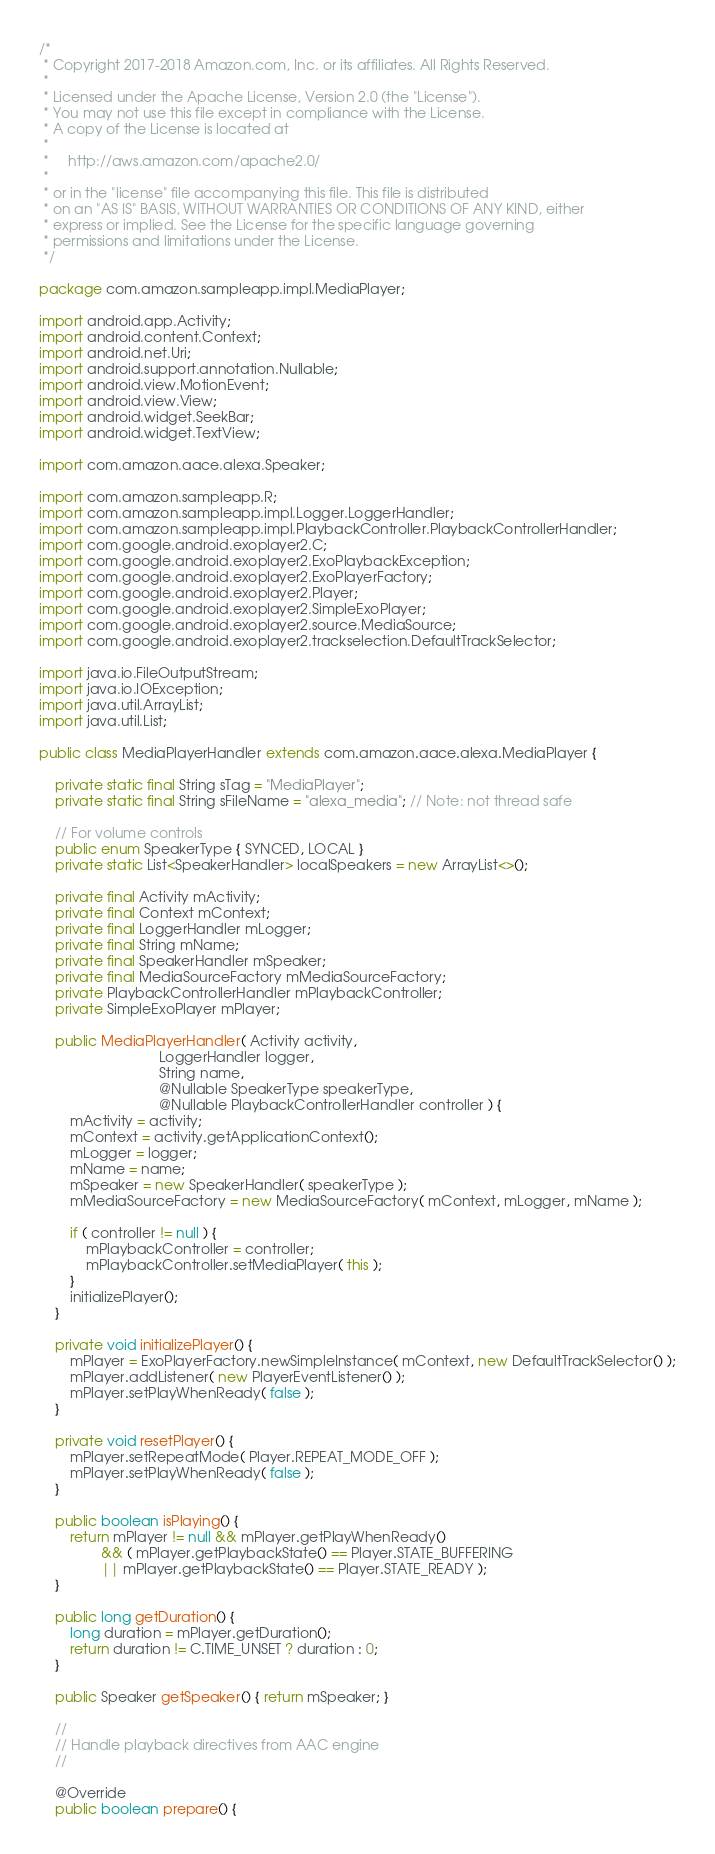<code> <loc_0><loc_0><loc_500><loc_500><_Java_>/*
 * Copyright 2017-2018 Amazon.com, Inc. or its affiliates. All Rights Reserved.
 *
 * Licensed under the Apache License, Version 2.0 (the "License").
 * You may not use this file except in compliance with the License.
 * A copy of the License is located at
 *
 *     http://aws.amazon.com/apache2.0/
 *
 * or in the "license" file accompanying this file. This file is distributed
 * on an "AS IS" BASIS, WITHOUT WARRANTIES OR CONDITIONS OF ANY KIND, either
 * express or implied. See the License for the specific language governing
 * permissions and limitations under the License.
 */

package com.amazon.sampleapp.impl.MediaPlayer;

import android.app.Activity;
import android.content.Context;
import android.net.Uri;
import android.support.annotation.Nullable;
import android.view.MotionEvent;
import android.view.View;
import android.widget.SeekBar;
import android.widget.TextView;

import com.amazon.aace.alexa.Speaker;

import com.amazon.sampleapp.R;
import com.amazon.sampleapp.impl.Logger.LoggerHandler;
import com.amazon.sampleapp.impl.PlaybackController.PlaybackControllerHandler;
import com.google.android.exoplayer2.C;
import com.google.android.exoplayer2.ExoPlaybackException;
import com.google.android.exoplayer2.ExoPlayerFactory;
import com.google.android.exoplayer2.Player;
import com.google.android.exoplayer2.SimpleExoPlayer;
import com.google.android.exoplayer2.source.MediaSource;
import com.google.android.exoplayer2.trackselection.DefaultTrackSelector;

import java.io.FileOutputStream;
import java.io.IOException;
import java.util.ArrayList;
import java.util.List;

public class MediaPlayerHandler extends com.amazon.aace.alexa.MediaPlayer {

    private static final String sTag = "MediaPlayer";
    private static final String sFileName = "alexa_media"; // Note: not thread safe

    // For volume controls
    public enum SpeakerType { SYNCED, LOCAL }
    private static List<SpeakerHandler> localSpeakers = new ArrayList<>();

    private final Activity mActivity;
    private final Context mContext;
    private final LoggerHandler mLogger;
    private final String mName;
    private final SpeakerHandler mSpeaker;
    private final MediaSourceFactory mMediaSourceFactory;
    private PlaybackControllerHandler mPlaybackController;
    private SimpleExoPlayer mPlayer;

    public MediaPlayerHandler( Activity activity,
                               LoggerHandler logger,
                               String name,
                               @Nullable SpeakerType speakerType,
                               @Nullable PlaybackControllerHandler controller ) {
        mActivity = activity;
        mContext = activity.getApplicationContext();
        mLogger = logger;
        mName = name;
        mSpeaker = new SpeakerHandler( speakerType );
        mMediaSourceFactory = new MediaSourceFactory( mContext, mLogger, mName );

        if ( controller != null ) {
            mPlaybackController = controller;
            mPlaybackController.setMediaPlayer( this );
        }
        initializePlayer();
    }

    private void initializePlayer() {
        mPlayer = ExoPlayerFactory.newSimpleInstance( mContext, new DefaultTrackSelector() );
        mPlayer.addListener( new PlayerEventListener() );
        mPlayer.setPlayWhenReady( false );
    }

    private void resetPlayer() {
        mPlayer.setRepeatMode( Player.REPEAT_MODE_OFF );
        mPlayer.setPlayWhenReady( false );
    }

    public boolean isPlaying() {
        return mPlayer != null && mPlayer.getPlayWhenReady()
                && ( mPlayer.getPlaybackState() == Player.STATE_BUFFERING
                || mPlayer.getPlaybackState() == Player.STATE_READY );
    }

    public long getDuration() {
        long duration = mPlayer.getDuration();
        return duration != C.TIME_UNSET ? duration : 0;
    }

    public Speaker getSpeaker() { return mSpeaker; }

    //
    // Handle playback directives from AAC engine
    //

    @Override
    public boolean prepare() {</code> 